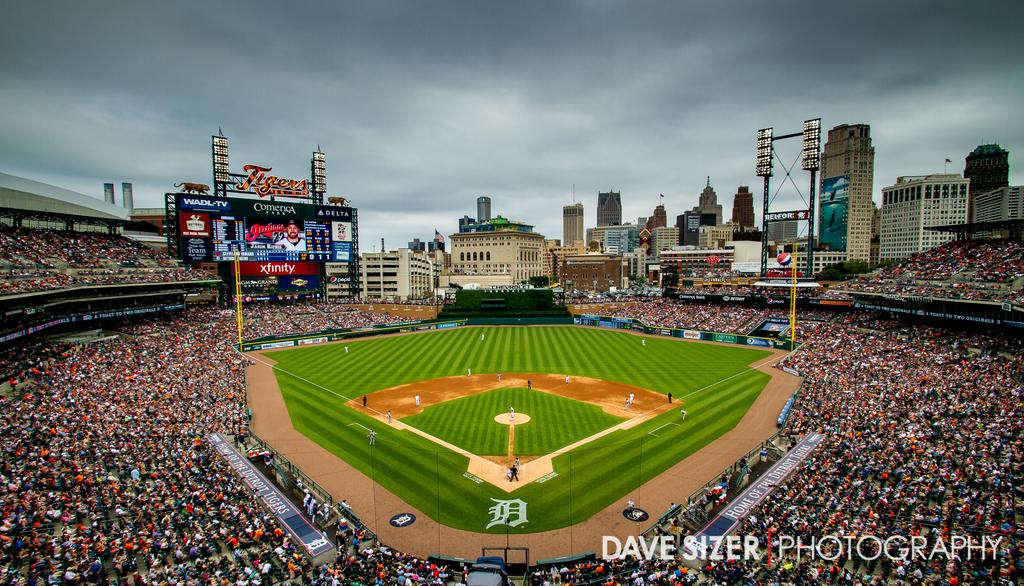<image>
Describe the image concisely. Baseball Stadium that is shown by Dave Sizer Photography. 